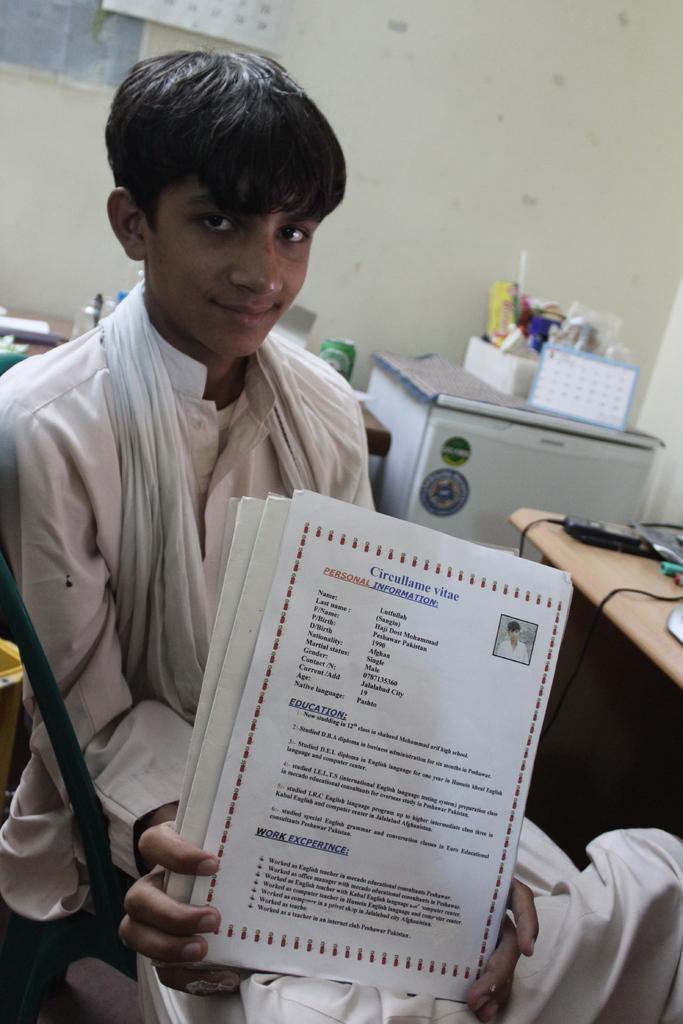How would you summarize this image in a sentence or two? In the foreground I can see a boy is sitting on a chair in front of a table and is holding certificates in hand. In the background I can see a wall, tables and some objects on it. This image is taken may be in a hall. 